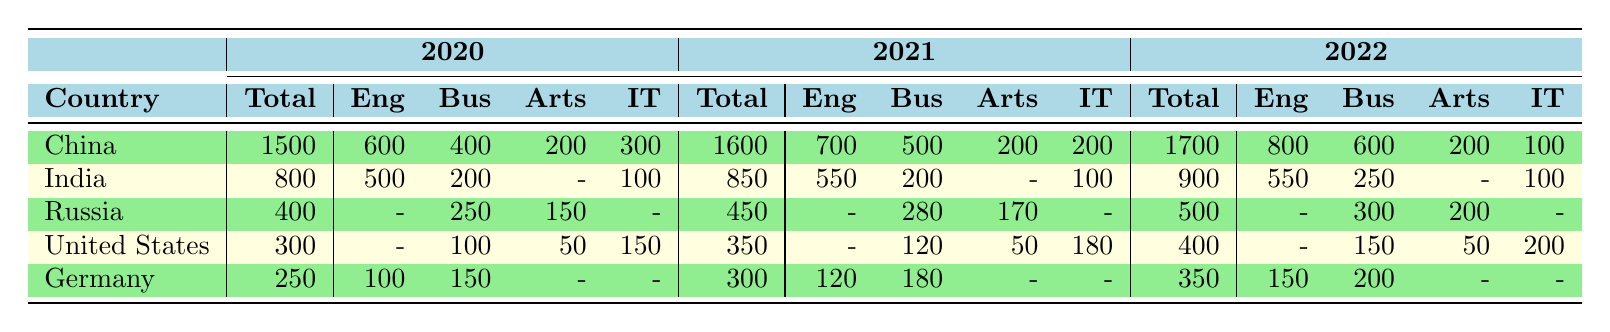What was the total number of foreign students from India in 2021? The table shows that the total number of foreign students from India in 2021 is listed in the second column under the 2021 heading. Referring to the table, the number is 850.
Answer: 850 Which program had the highest enrollment from China in 2022? To determine this, we look at the breakdown of students from China in 2022. The numbers for each program are Engineering (800), Business (600), Arts (200), and IT (100). The highest number is in Engineering.
Answer: Engineering How many total foreign students were enrolled from Russia in 2020 and 2021 combined? We find the total from Russia in 2020, which is 400, and in 2021, which is 450. Adding these together gives us 400 + 450 = 850.
Answer: 850 Was the number of students from the United States larger in 2021 than in 2020? The table shows 350 students from the United States in 2021 and 300 in 2020. Since 350 is greater than 300, the answer is yes.
Answer: Yes What percentage of total foreign students from China in 2021 were enrolled in Arts programs? The total number of students from China in 2021 is 1600, and the number enrolled in Arts programs is 200. To find the percentage, we calculate (200/1600) * 100 = 12.5%.
Answer: 12.5% Which country had the highest total number of foreign students in 2022? We look at the totals for each country in 2022: China (1700), India (900), Russia (500), United States (400), and Germany (350). Comparing these, China has the highest total of 1700 students.
Answer: China How many foreign students from Germany were enrolled in Engineering programs in 2020? Referring to the table, we see that the total number of students from Germany in Engineering in 2020 is 100, which is listed under the Engineering column for Germany.
Answer: 100 Is there a significant increase in the total number of students from India from 2020 to 2022? The total for India in 2020 was 800, and in 2022 it was 900. The change is 900 - 800 = 100, which is an increase but not very significant; it represents a 12.5% increase. So, while there is an increase, its significance may vary based on context.
Answer: Yes, but not very significant 